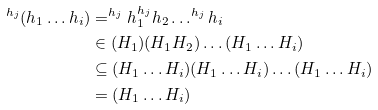Convert formula to latex. <formula><loc_0><loc_0><loc_500><loc_500>^ { h _ { j } } ( h _ { 1 } \dots h _ { i } ) & = ^ { h _ { j } } h _ { 1 } ^ { h _ { j } } h _ { 2 } \dots ^ { h _ { j } } h _ { i } \\ & \in ( H _ { 1 } ) ( H _ { 1 } H _ { 2 } ) \dots ( H _ { 1 } \dots H _ { i } ) \\ & \subseteq ( H _ { 1 } \dots H _ { i } ) ( H _ { 1 } \dots H _ { i } ) \dots ( H _ { 1 } \dots H _ { i } ) \\ & = ( H _ { 1 } \dots H _ { i } )</formula> 